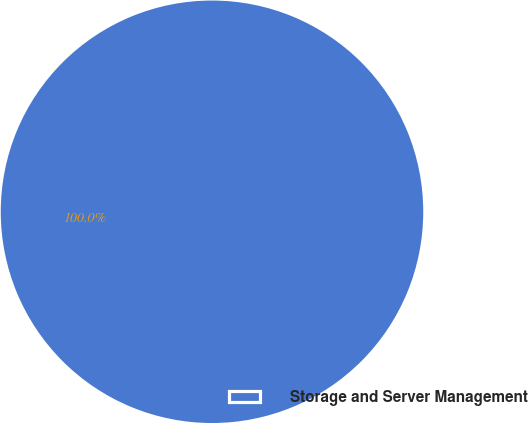Convert chart. <chart><loc_0><loc_0><loc_500><loc_500><pie_chart><fcel>Storage and Server Management<nl><fcel>100.0%<nl></chart> 